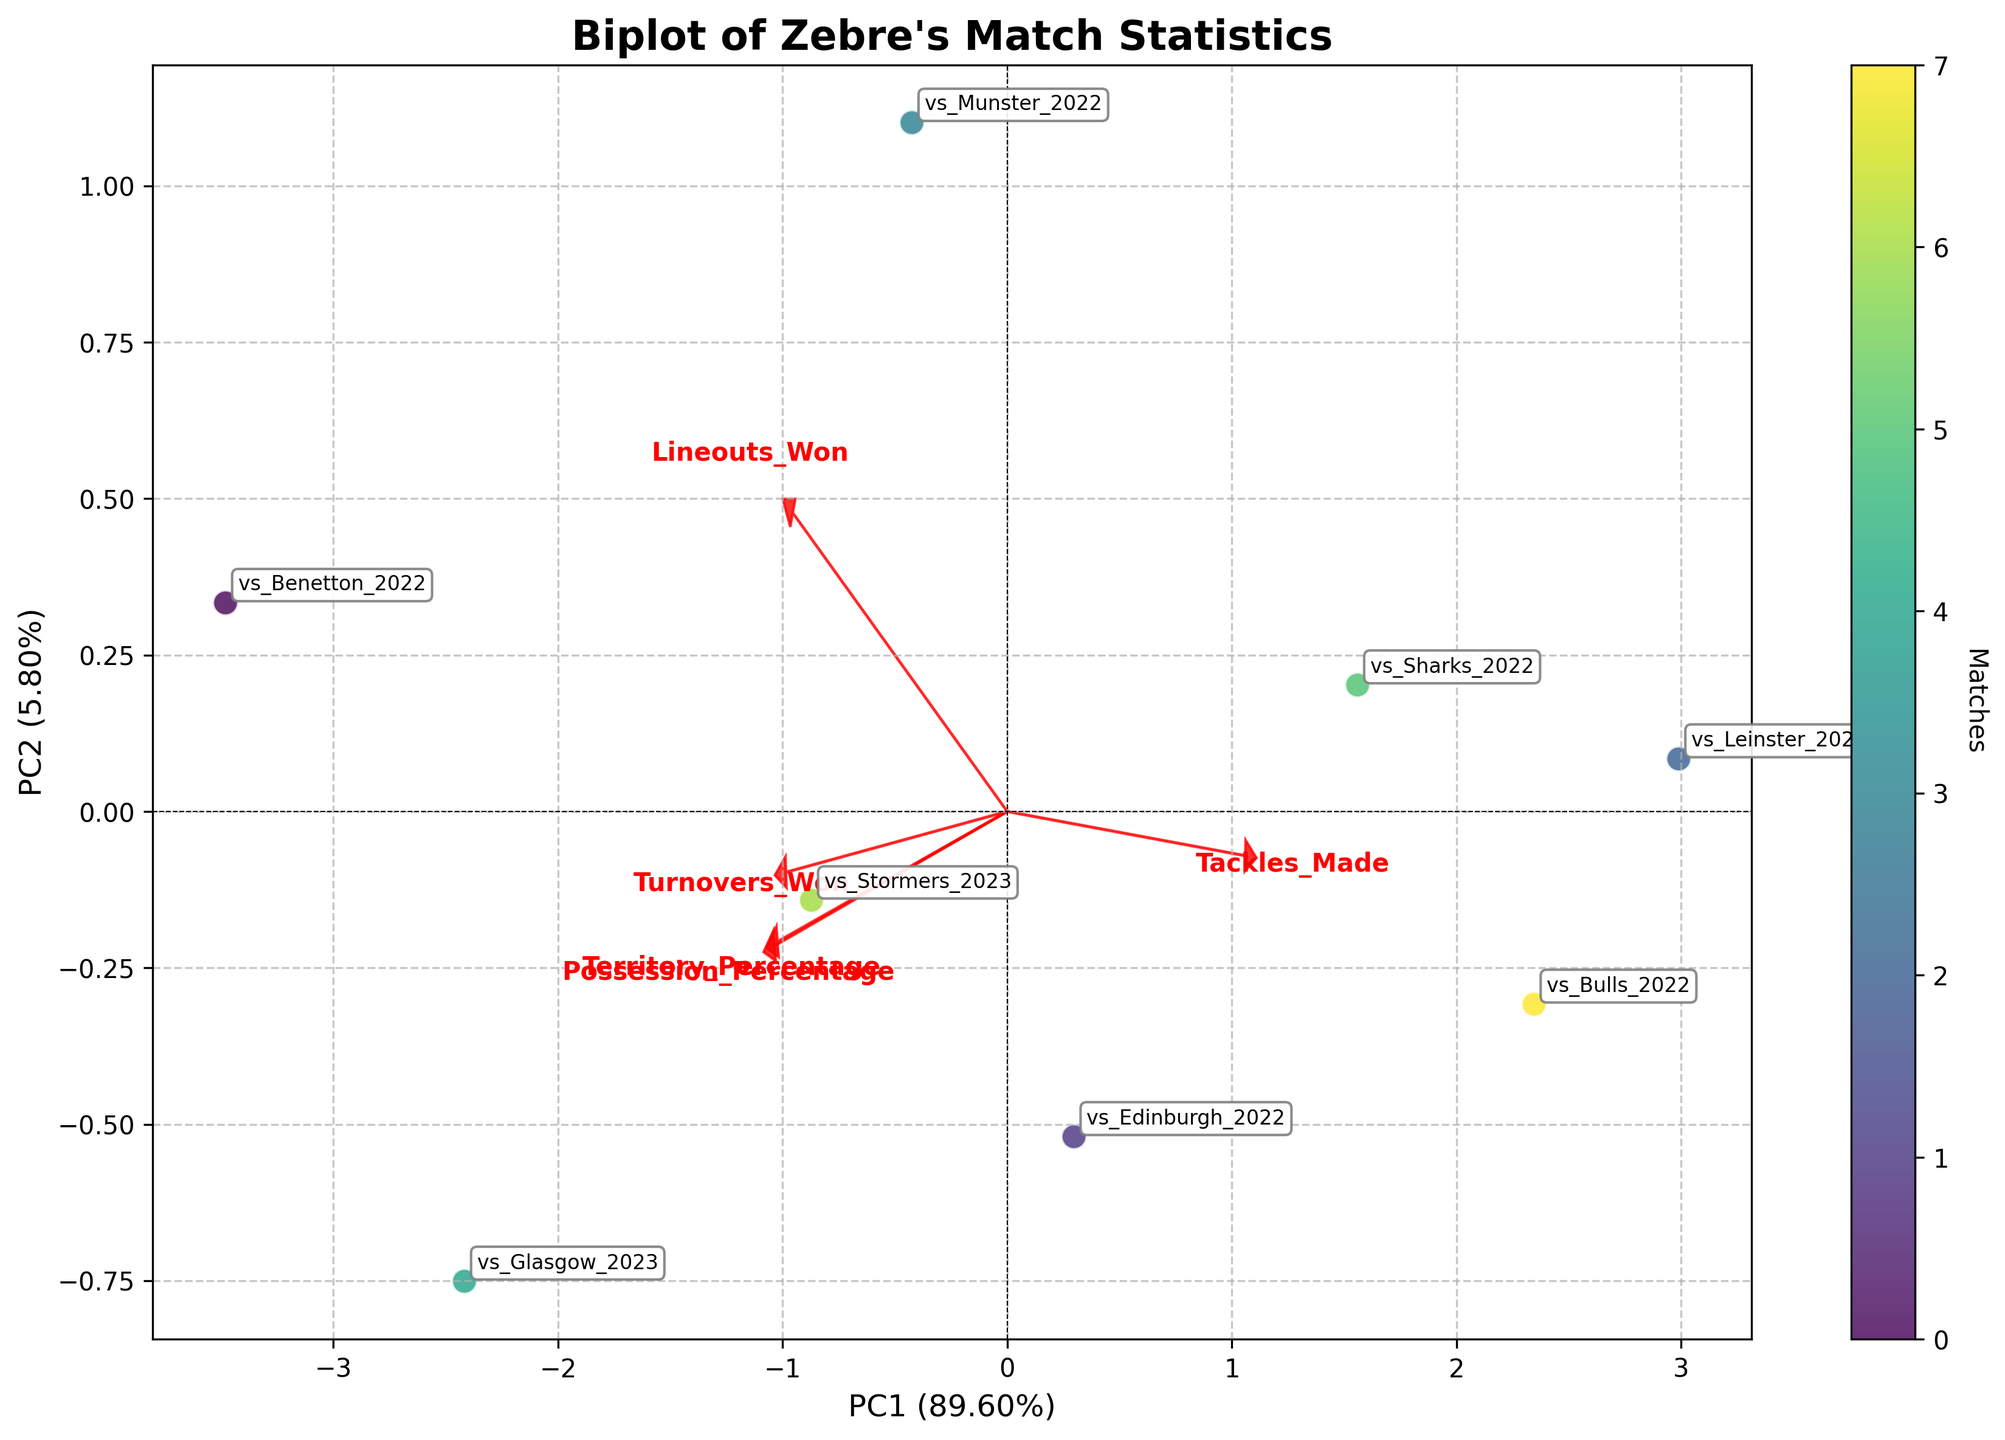What's the title of the plot? The title is located at the top center of the plot. By observing the plot, you can see that it reads "Biplot of Zebre's Match Statistics".
Answer: Biplot of Zebre's Match Statistics How many matches are represented in the biplot? Each match is represented by a point, and there are labels next to each point. Counting the labels will give the total number of matches. There are 8 labels visible.
Answer: 8 Which match has the highest PC1 score? The PC1 score is represented by the x-axis. Identifying the rightmost point on the x-axis will reveal the match with the highest PC1 score. The rightmost point appears to be labeled "vs_Glasgow_2023".
Answer: vs_Glasgow_2023 Which match has the lowest PC2 score? The PC2 score is represented by the y-axis. Identifying the lowest point on the y-axis will reveal the match with the lowest PC2 score. The lowest point appears to be labeled "vs_Leinster_2023".
Answer: vs_Leinster_2023 Which variable contributes most to PC1? Variables contributing to PC1 can be identified by looking at the direction and length of the arrows in the plot. The arrow pointing furthest in the horizontal direction (along PC1) represents the highest contributor to PC1. The "Tackles_Made" arrow stretches furthest horizontally.
Answer: Tackles_Made What's the combined contribution (variance ratio) of PC1 and PC2? The percentage of explained variance by PC1 and PC2 is shown in the axis labels. Summing them gives the total contribution. PC1 shows 47% and PC2 shows 23%, so the combined is 47% + 23% = 70%.
Answer: 70% Which matches have very similar possession and territory statistics based on the biplot? Matches with similar possession and territory statistics will appear close to each other on the plot. "vs_Benetton_2022" and "vs_Glasgow_2023" are positioned near each other, indicating similarity.
Answer: vs_Benetton_2022, vs_Glasgow_2023 How does "Turnovers_Won" correlate with other variables according to the plot? To determine this, observe the direction and length of the "Turnovers_Won" arrow relative to others. It points nearly opposite to "Tackles_Made", suggesting a negative correlation, and somewhat differently to "Lineouts_Won" and "Possession_Percentage" indicating varying correlations.
Answer: Negative with Tackles_Made What can be inferred about the match "vs_Benetton_2022" based on its position in the biplot? Looking at the position, "vs_Benetton_2022" being close to the origin suggests it has average statistics for most variables. It neither stands out positively nor negatively in any specific measurements.
Answer: Average statistics How does "Possession_Percentage" influence PC2? Looking at the "Possession_Percentage" arrow, its length and direction vertically correlate with PC2. Since the arrow towards the top indicates a positive influence, greater possession percentage means a higher PC2 value.
Answer: Positive influence 